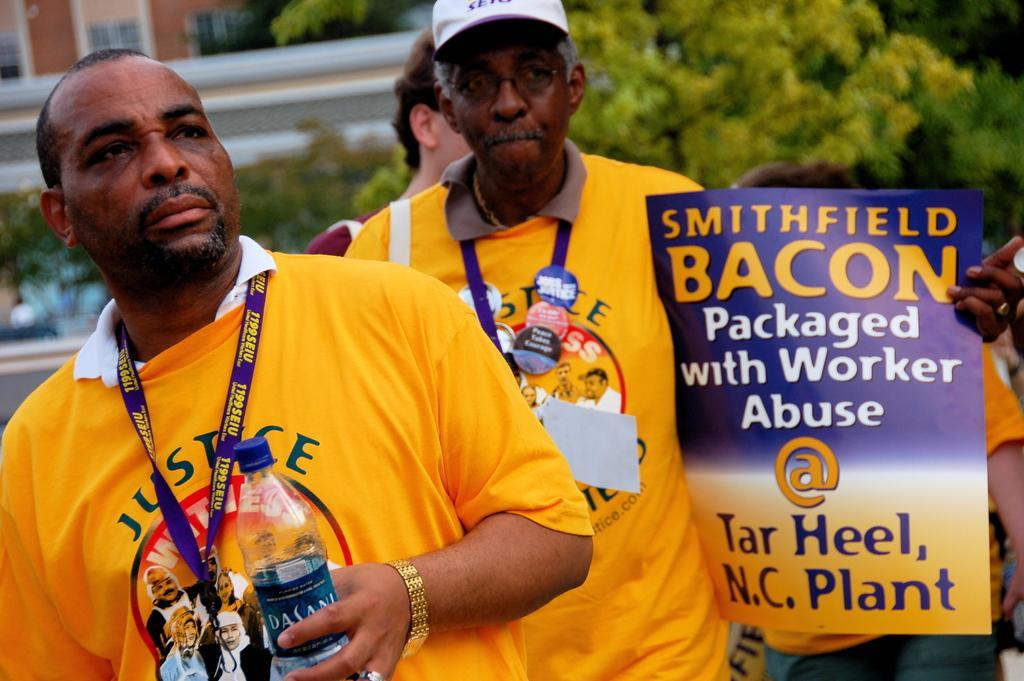How would you summarize this image in a sentence or two? In this image I can see the group of people with yellow, white and maroon color dresses. I can also see one person with the cap. I can see one person holding the bottle and can another person holding the pamphlet. In the background I can see many trees and the building. 